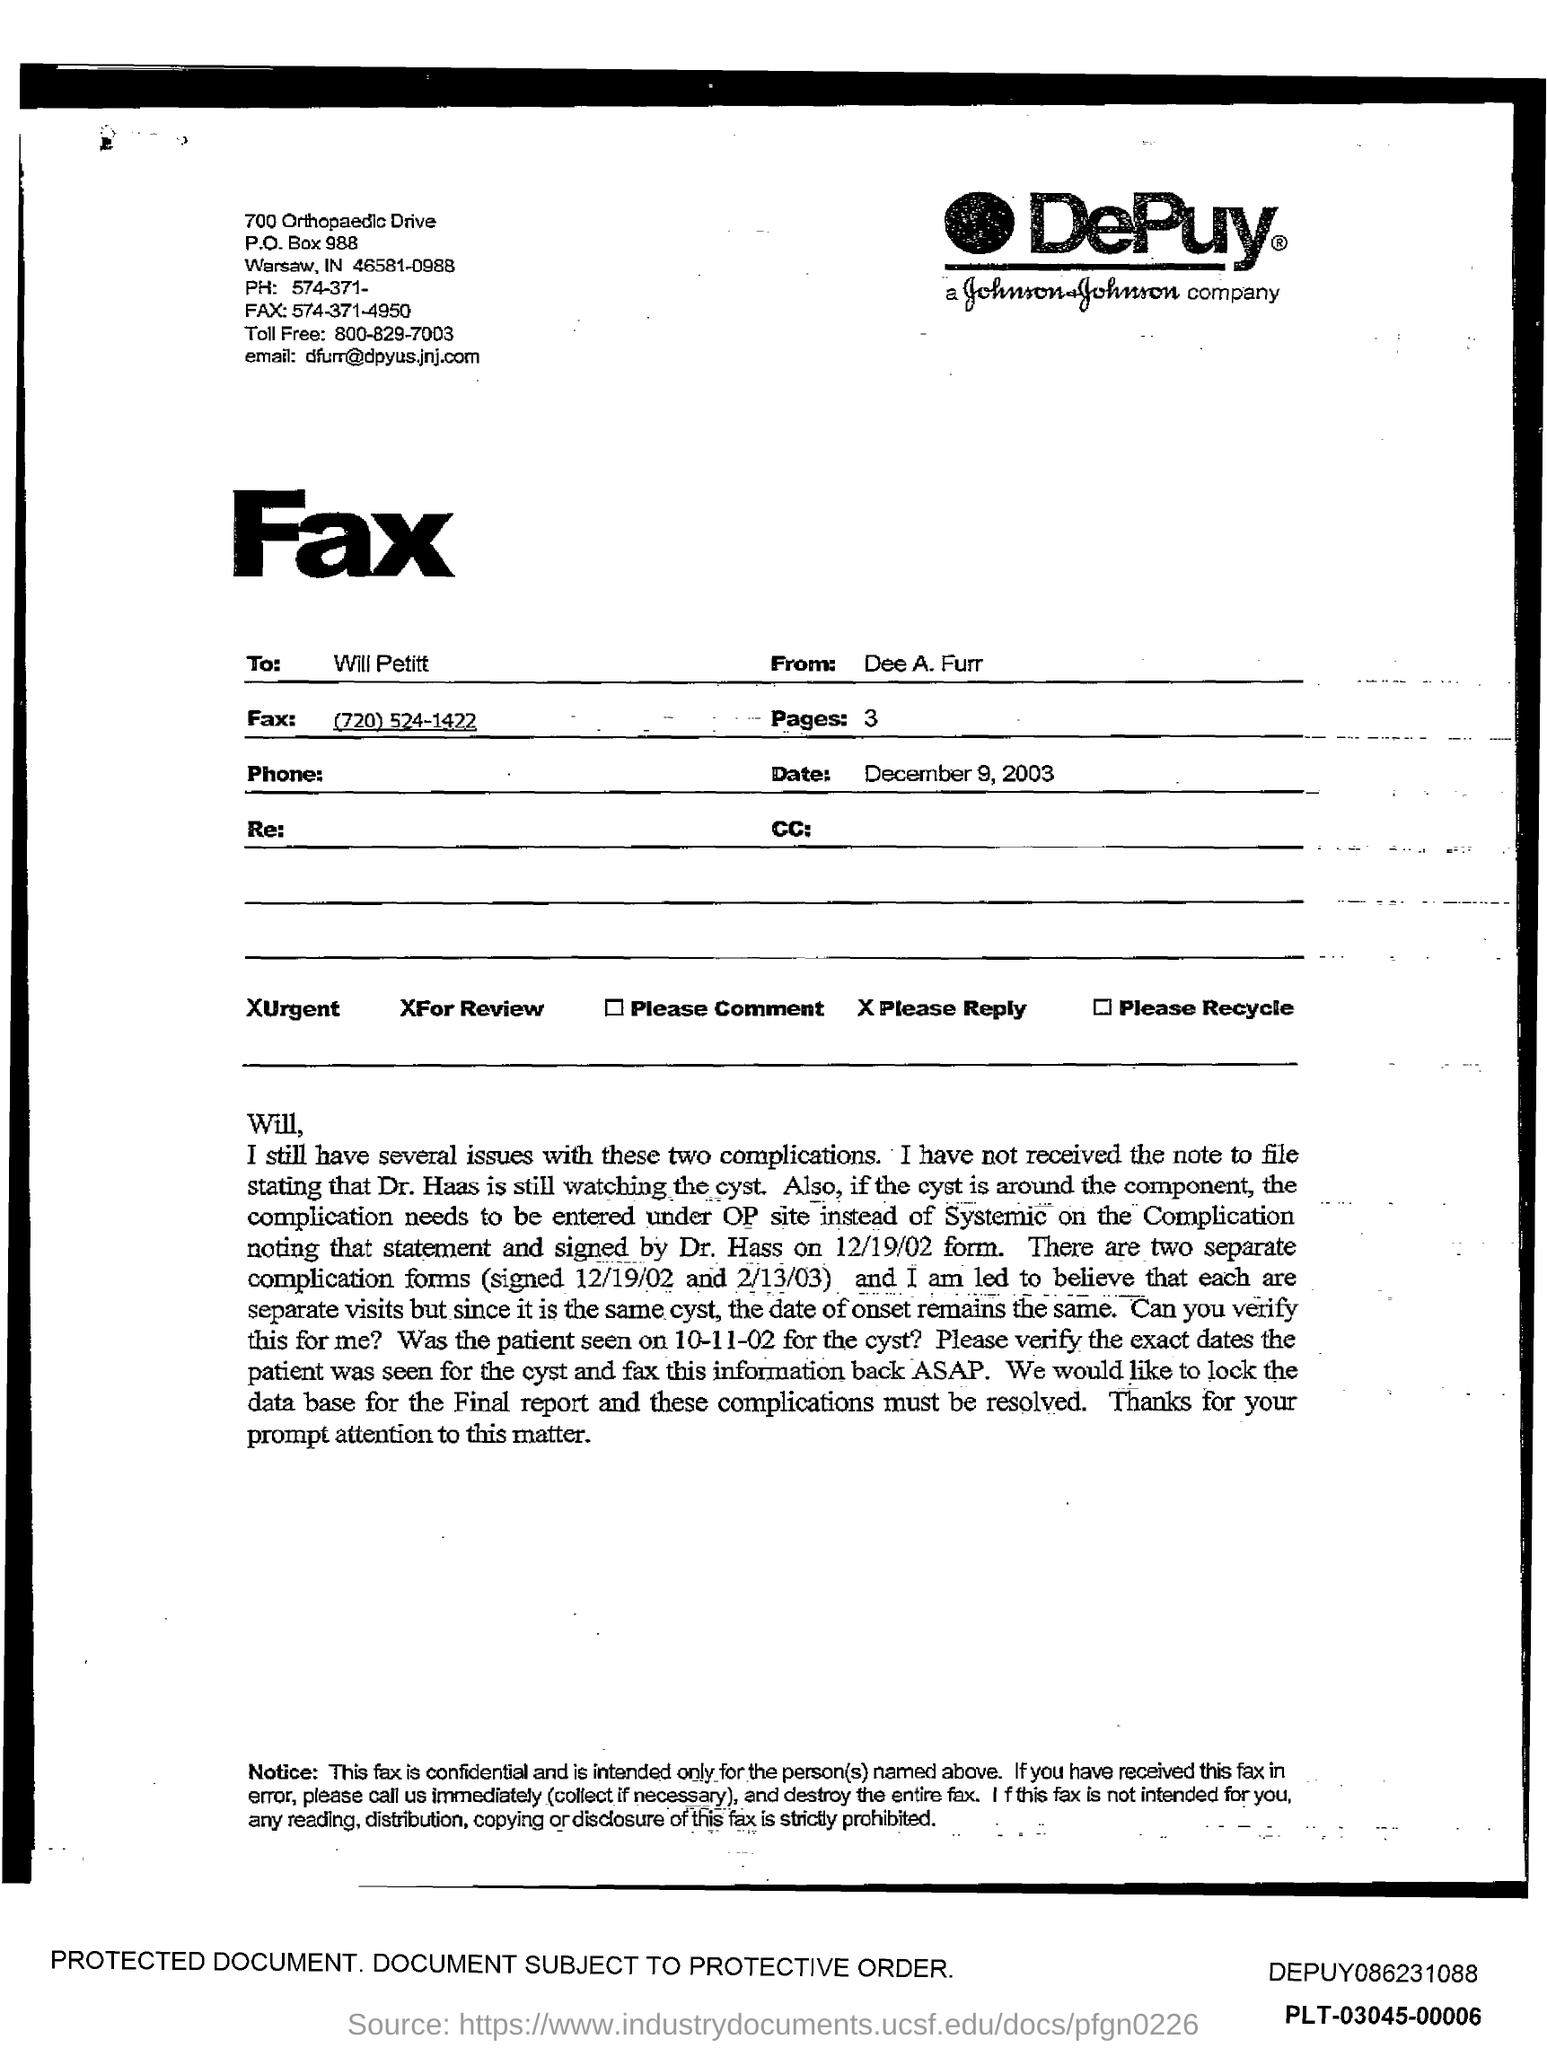Who is the sender of the Fax?
Offer a very short reply. Dee A. Furr. Who is the receiver of the Fax?
Provide a succinct answer. Will Petitt. What is the Fax No given?
Provide a short and direct response. (720) 524-1422. What is the number of pages in the fax?
Your answer should be compact. 3. 